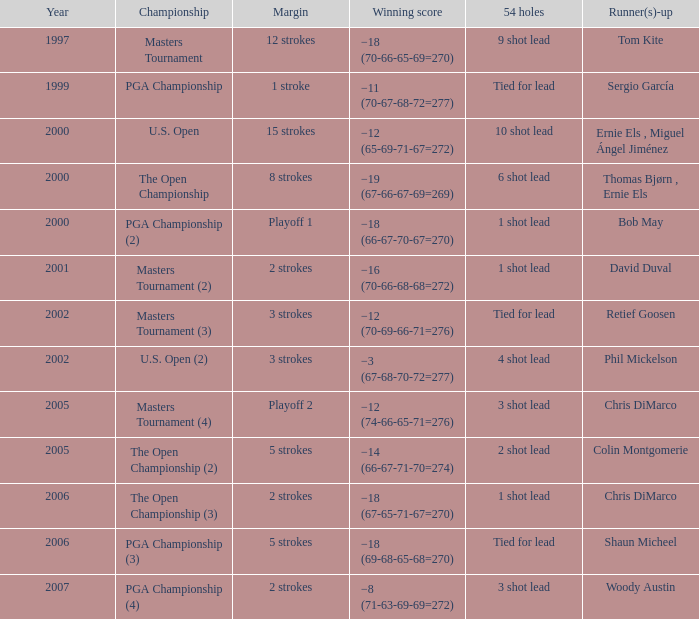 who is the runner(s)-up where 54 holes is tied for lead and margin is 5 strokes Shaun Micheel. 